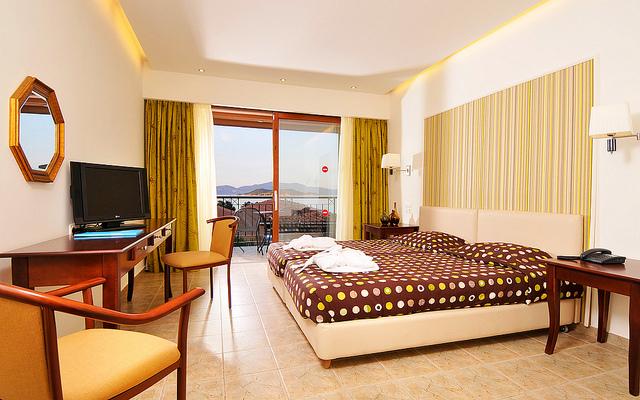Is this hotel near a body of water?
Answer briefly. Yes. How many beds are there?
Quick response, please. 2. Is this hotel room on the first floor?
Quick response, please. No. 